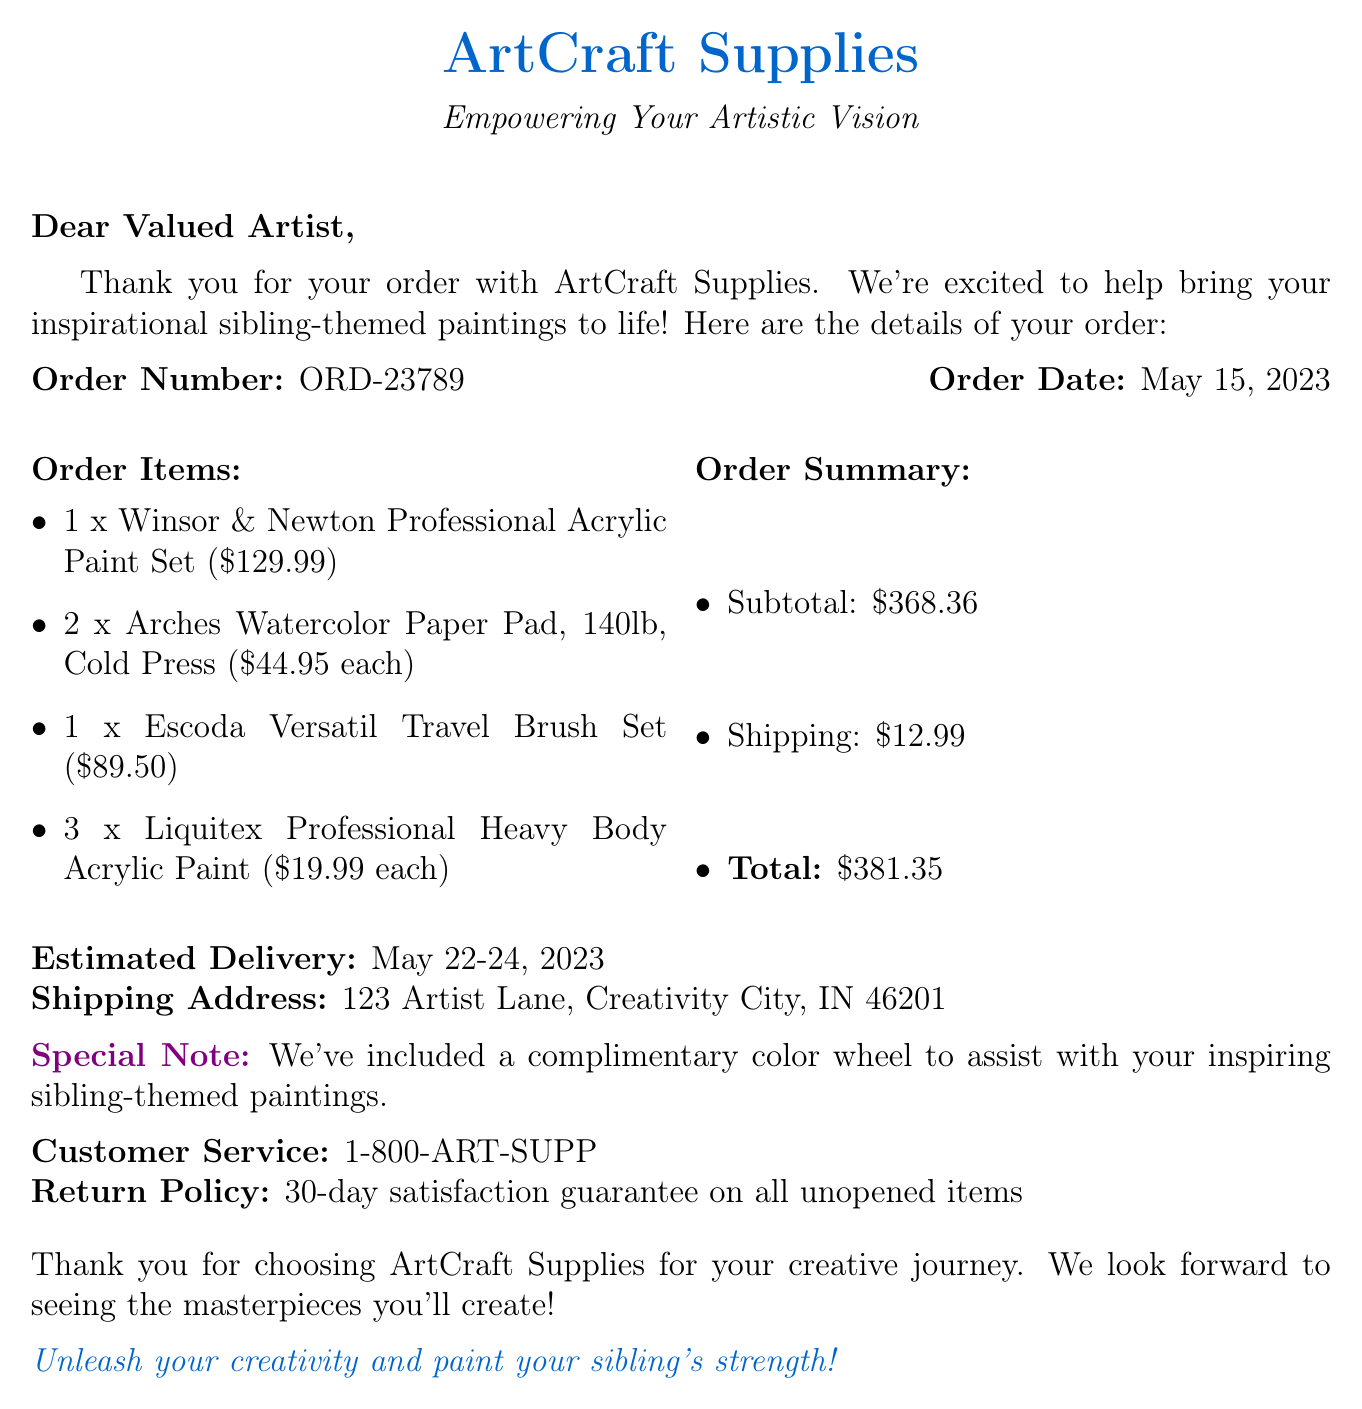What is the order number? The order number is specified in the document as a unique identifier for the order.
Answer: ORD-23789 How many Arches Watercolor Paper Pads were ordered? The document lists the quantity of Arches Watercolor Paper Pads included in the order.
Answer: 2 What is the total cost of the order? The total cost is calculated by summing the subtotal and shipping costs given in the order summary.
Answer: $381.35 When was the order placed? The order date is explicitly mentioned in the document for reference.
Answer: May 15, 2023 What is included as a special note in the order? The special note highlights an extra item added to assist with the artistic process.
Answer: A complimentary color wheel What is the estimated delivery date range? The document provides a range of dates during which the order is expected to be delivered.
Answer: May 22-24, 2023 What is the return policy for items? The return policy is specified for customers regarding their ability to return products.
Answer: 30-day satisfaction guarantee on all unopened items What type of items were ordered? The order details the kinds of art supplies purchased, which reveals the purpose of the order.
Answer: Art supplies What is the customer service contact number? A contact number is provided for reaching customer service regarding the order.
Answer: 1-800-ART-SUPP 